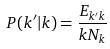<formula> <loc_0><loc_0><loc_500><loc_500>P ( k ^ { \prime } | k ) = \frac { E _ { k ^ { \prime } k } } { k N _ { k } }</formula> 